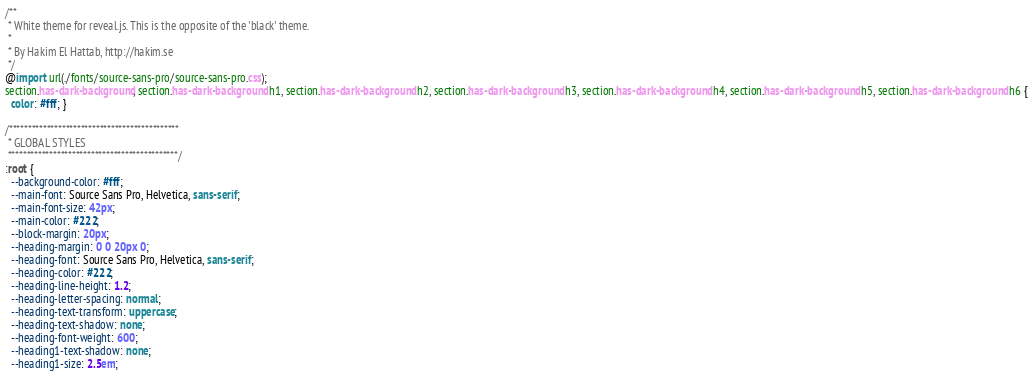<code> <loc_0><loc_0><loc_500><loc_500><_CSS_>/**
 * White theme for reveal.js. This is the opposite of the 'black' theme.
 *
 * By Hakim El Hattab, http://hakim.se
 */
@import url(./fonts/source-sans-pro/source-sans-pro.css);
section.has-dark-background, section.has-dark-background h1, section.has-dark-background h2, section.has-dark-background h3, section.has-dark-background h4, section.has-dark-background h5, section.has-dark-background h6 {
  color: #fff; }

/*********************************************
 * GLOBAL STYLES
 *********************************************/
:root {
  --background-color: #fff;
  --main-font: Source Sans Pro, Helvetica, sans-serif;
  --main-font-size: 42px;
  --main-color: #222;
  --block-margin: 20px;
  --heading-margin: 0 0 20px 0;
  --heading-font: Source Sans Pro, Helvetica, sans-serif;
  --heading-color: #222;
  --heading-line-height: 1.2;
  --heading-letter-spacing: normal;
  --heading-text-transform: uppercase;
  --heading-text-shadow: none;
  --heading-font-weight: 600;
  --heading1-text-shadow: none;
  --heading1-size: 2.5em;</code> 